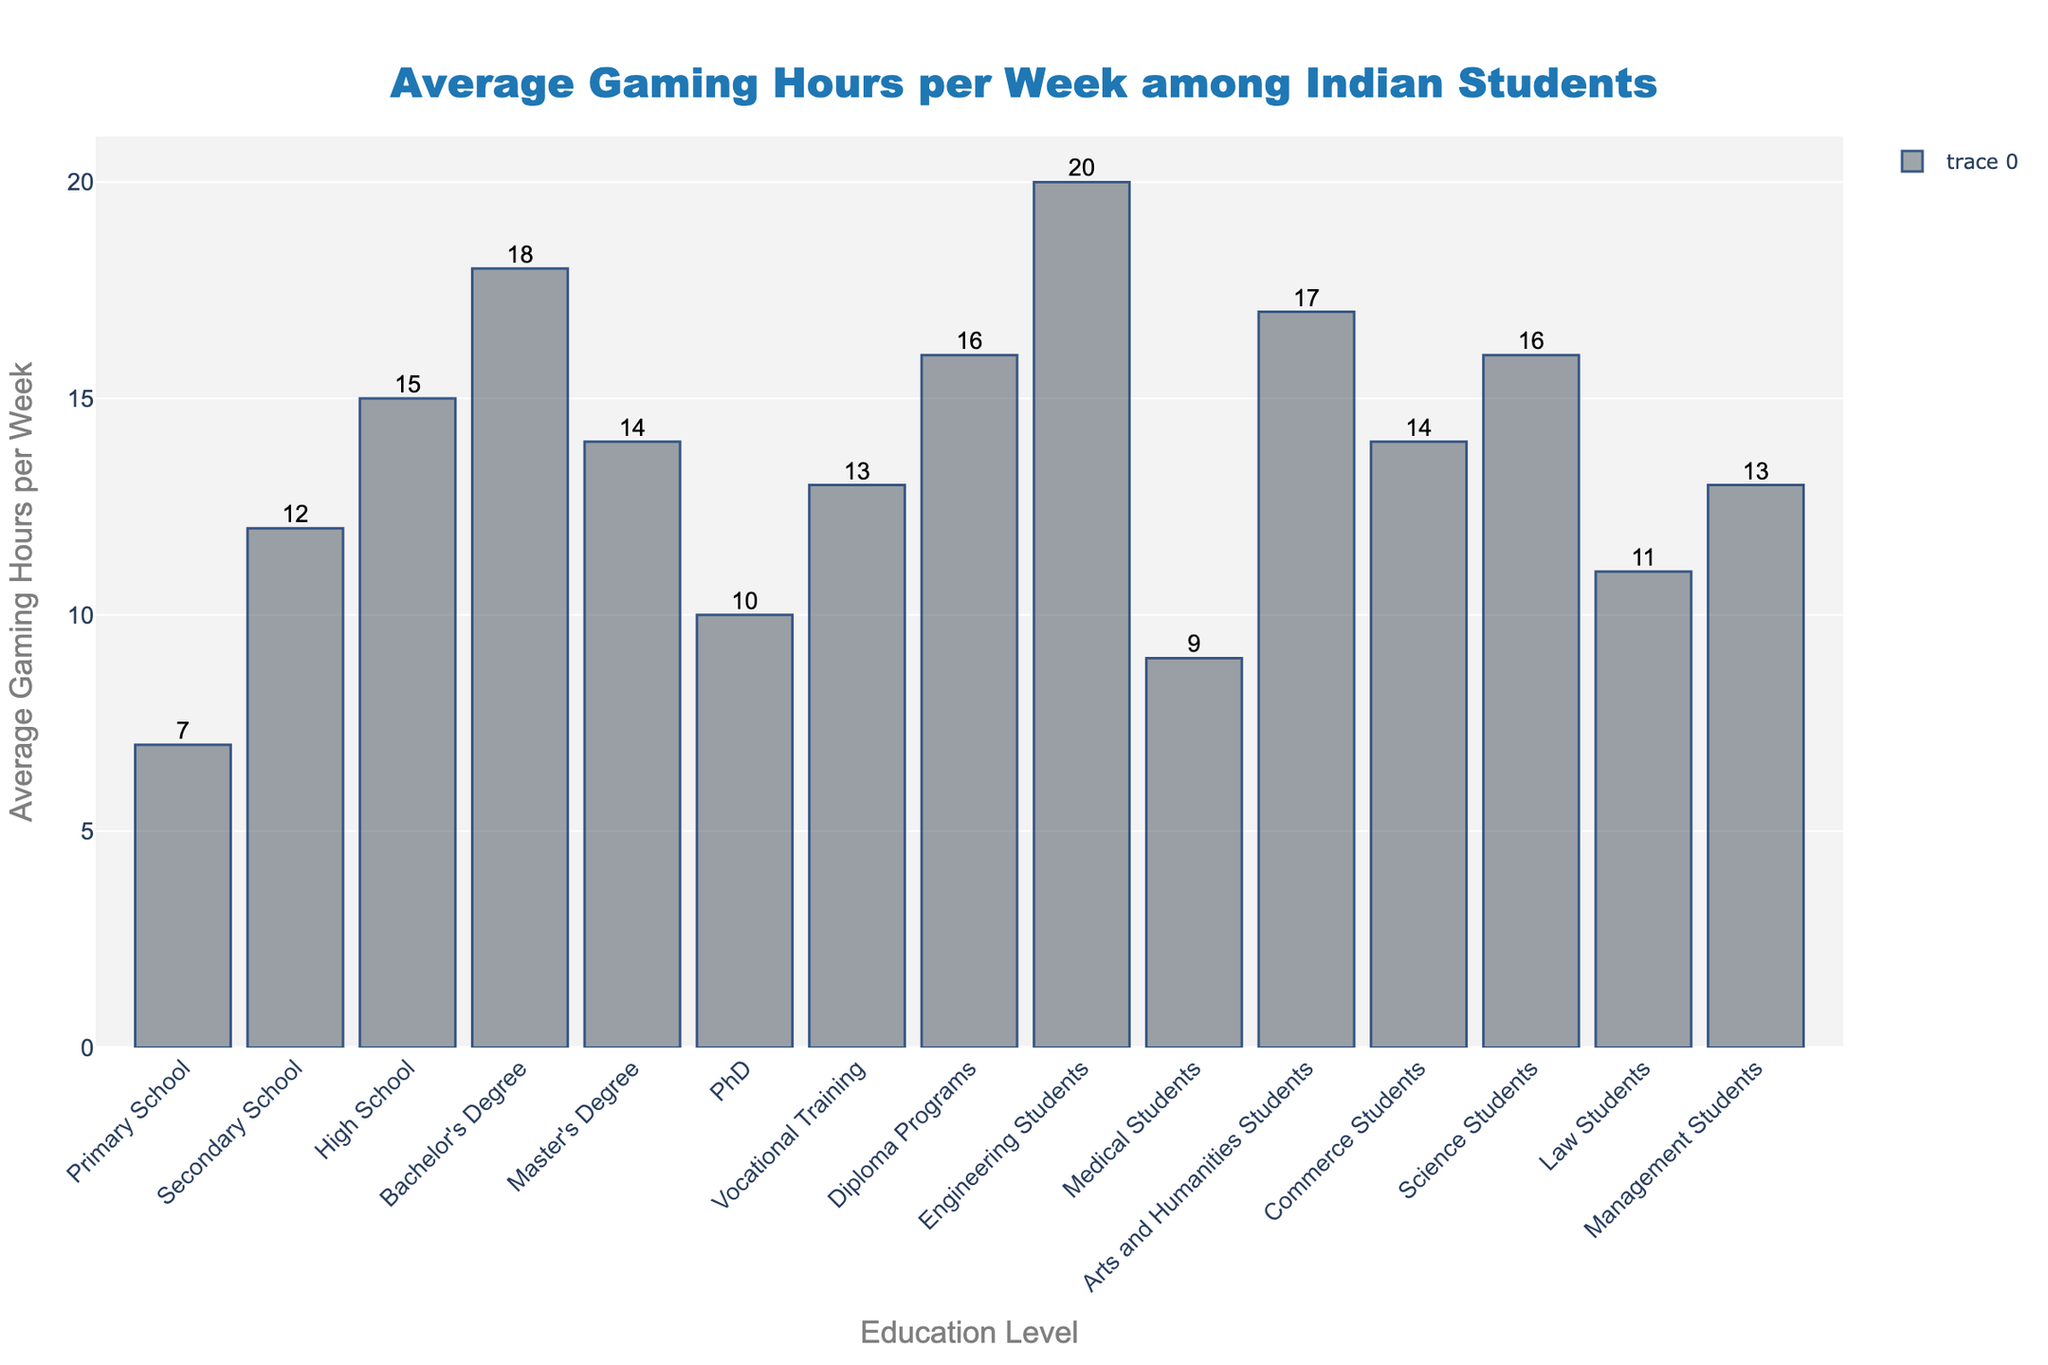Which education level has the highest average gaming hours per week? The tallest bar in the chart represents the education level with the highest average gaming hours per week. From the figure, the tallest bar corresponds to 'Engineering Students'.
Answer: Engineering Students How much higher are the average gaming hours for Engineering Students compared to Medical Students? To find this, subtract the height of the Medical Students bar from the height of the Engineering Students bar. Engineering Students have an average of 20 hours, and Medical Students have 9 hours. So, 20 - 9 = 11 hours.
Answer: 11 hours Which group has the lowest average gaming hours per week? The shortest bar in the bar chart indicates the group with the lowest average gaming hours per week. The shortest bar corresponds to 'Medical Students'.
Answer: Medical Students What is the combined average gaming hours for Commerce Students and Science Students? Add the average gaming hours for Commerce Students and Science Students. Commerce Students have 14 hours, and Science Students have 16 hours. So, 14 + 16 = 30 hours.
Answer: 30 hours Is the average gaming hours per week for Bachelor's Degree students greater than that for Master's Degree students? Compare the height of the bar for Bachelor's Degree to the height of the bar for Master's Degree. The Bachelor's Degree bar shows 18 hours, while the Master's Degree bar shows 14 hours. 18 is greater than 14.
Answer: Yes How does the average gaming hours per week for High School students compare to that for Primary School students? Subtract the average gaming hours for Primary School students from that for High School students. High School students spend 15 hours, while Primary School students spend 7 hours. So, 15 - 7 = 8 hours.
Answer: 8 hours more What is the difference in average gaming hours per week between Vocational Training students and Law Students? Subtract the average gaming hours for Law Students from that for Vocational Training students. Vocational Training students spend 13 hours on average, and Law Students spend 11 hours. So, 13 - 11 = 2 hours.
Answer: 2 hours Which two groups have the same average gaming hours per week? Look for bars with the same height. Both Commerce Students and Master's Degree students have bars representing 14 average gaming hours per week.
Answer: Commerce Students and Master's Degree students Sum of average gaming hours per week for High School and Diploma Programs students? Add the average gaming hours for High School students and Diploma Programs students. High School students have 15 hours, and Diploma Programs students have 16 hours. So, 15 + 16 = 31 hours.
Answer: 31 hours 